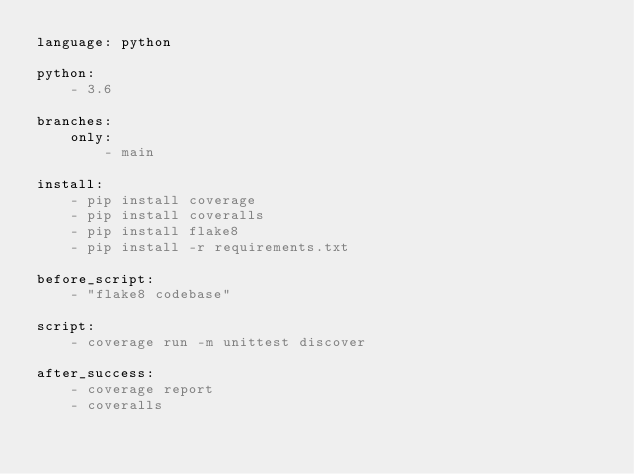Convert code to text. <code><loc_0><loc_0><loc_500><loc_500><_YAML_>language: python

python:
    - 3.6

branches:
    only:
        - main

install:
    - pip install coverage
    - pip install coveralls
    - pip install flake8
    - pip install -r requirements.txt

before_script:
    - "flake8 codebase"

script:
    - coverage run -m unittest discover

after_success:
    - coverage report
    - coveralls</code> 